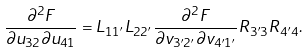Convert formula to latex. <formula><loc_0><loc_0><loc_500><loc_500>\frac { \partial ^ { 2 } F } { \partial u _ { 3 2 } \partial u _ { 4 1 } } = L _ { 1 1 ^ { \prime } } L _ { 2 2 ^ { \prime } } \frac { \partial ^ { 2 } F } { \partial v _ { 3 ^ { \prime } 2 ^ { \prime } } \partial v _ { 4 ^ { \prime } 1 ^ { \prime } } } R _ { 3 ^ { \prime } 3 } R _ { 4 ^ { \prime } 4 } .</formula> 